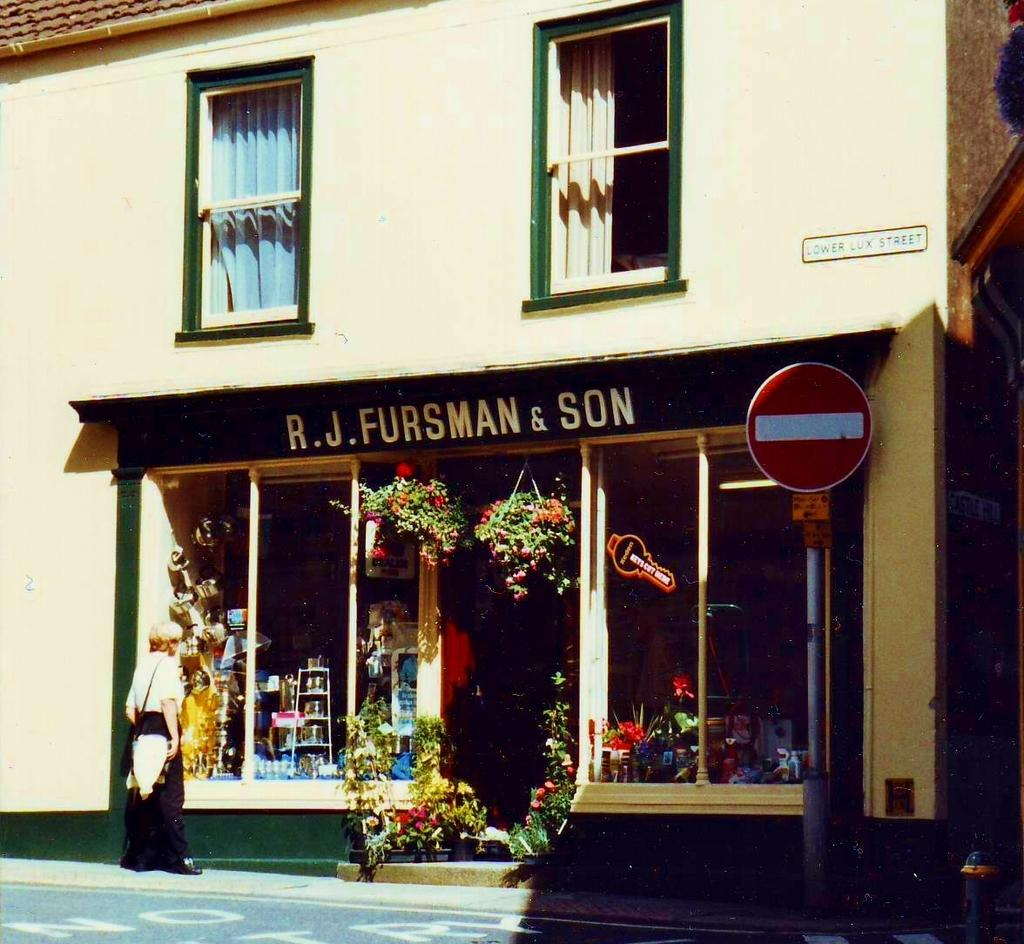What type of business is depicted in the image? There is a flower shop in the image. How many glass windows are visible in the image? There are two glass windows visible in the image. What color is the building wall in the image? The building wall is yellow. What type of board is hanging on the wall in the flower shop? There is no board visible in the image; only the flower shop, glass windows, and yellow building wall are present. 